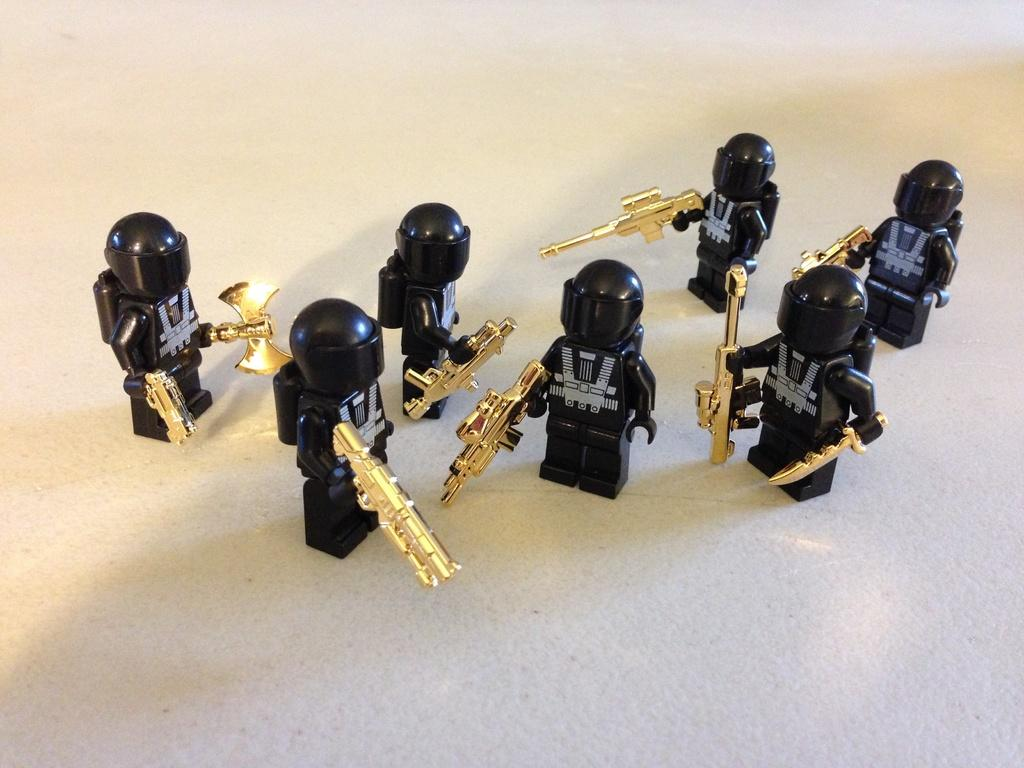What objects can be seen in the image? There are toys in the image. What surface is visible in the image? There is a floor visible in the image. What type of celery is being used as a whip in the image? There is no celery or whip present in the image; it only features toys and a floor. 